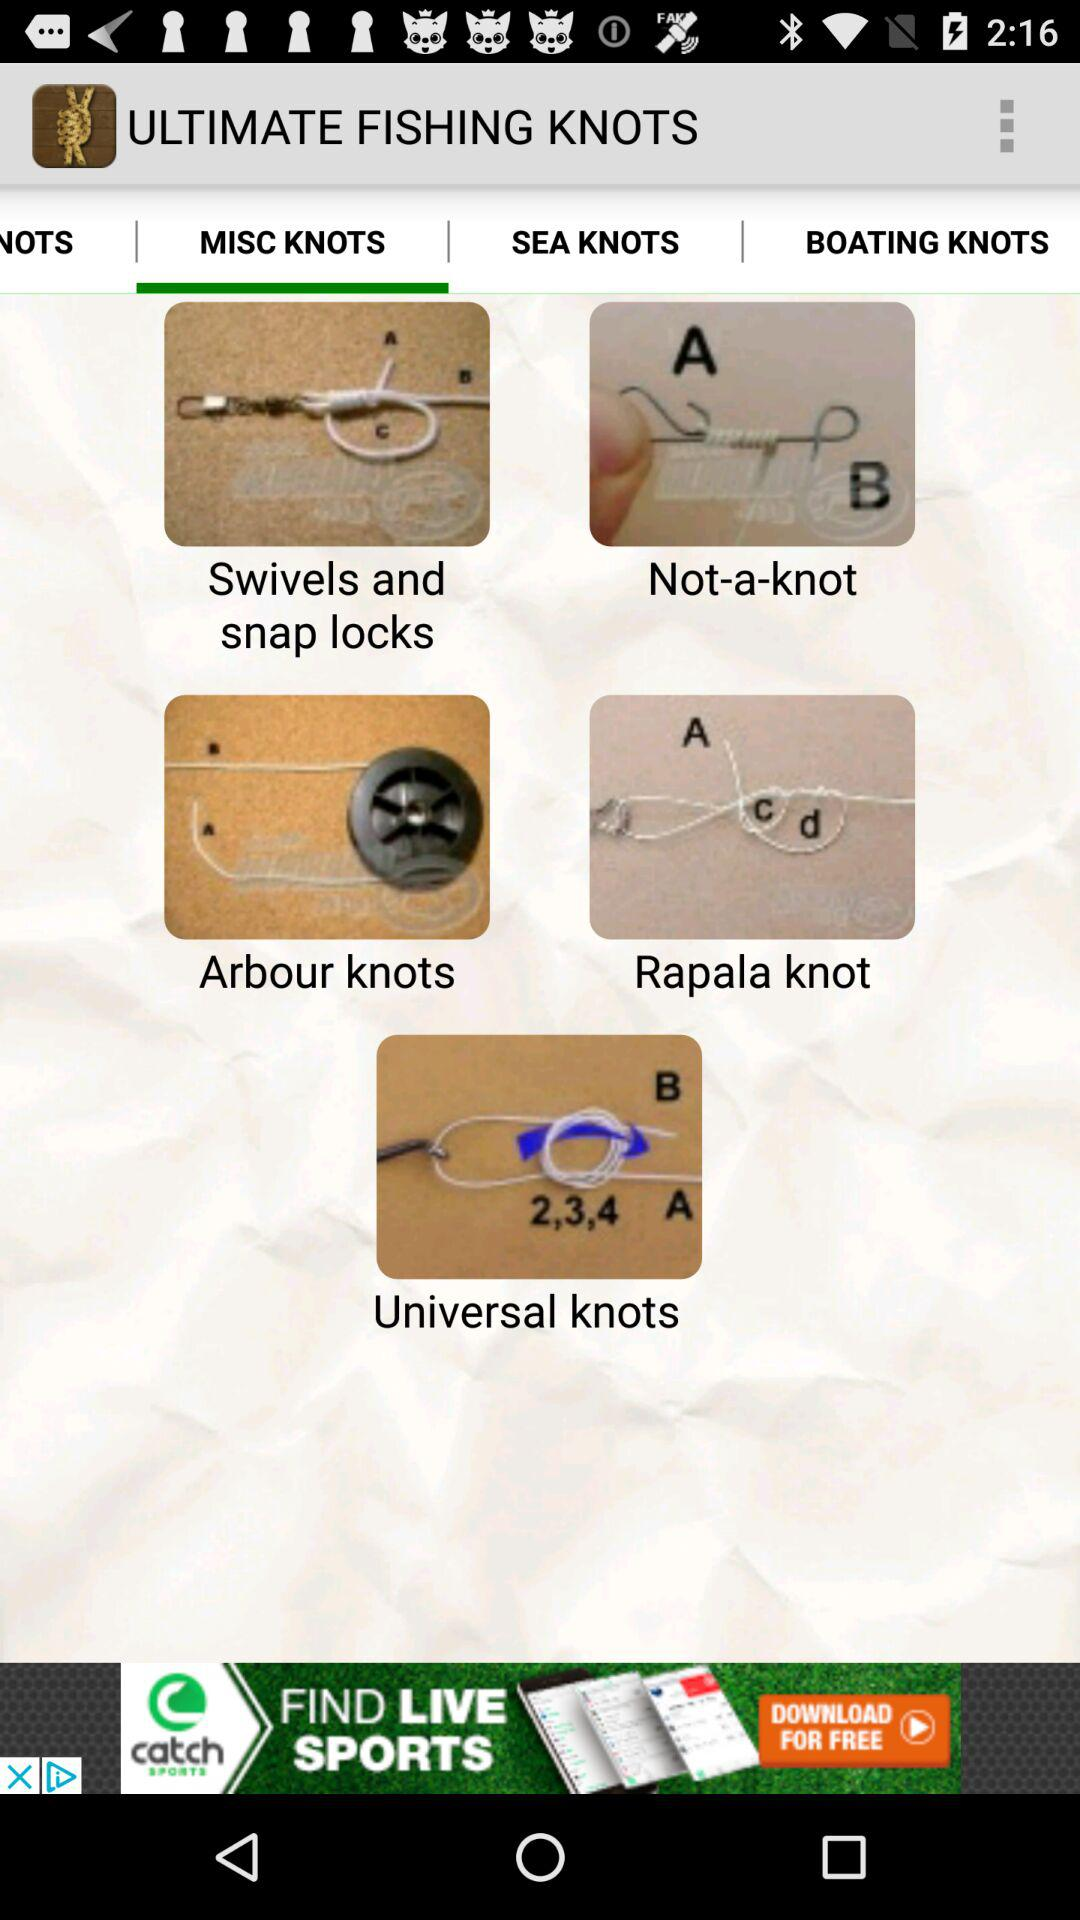Which tab is selected for "ULTIMATE FISHING KNOTS"? The selected tab is "MISC KNOTS". 